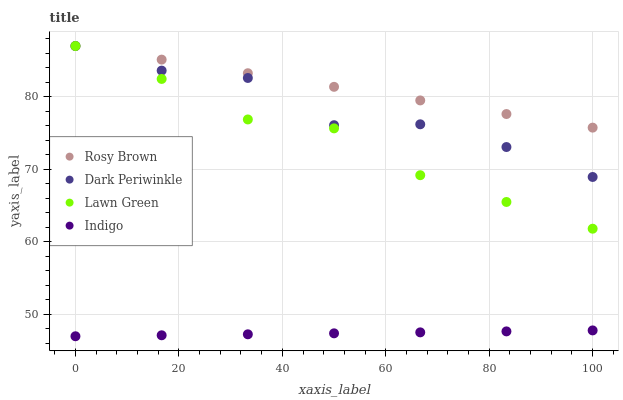Does Indigo have the minimum area under the curve?
Answer yes or no. Yes. Does Rosy Brown have the maximum area under the curve?
Answer yes or no. Yes. Does Rosy Brown have the minimum area under the curve?
Answer yes or no. No. Does Indigo have the maximum area under the curve?
Answer yes or no. No. Is Rosy Brown the smoothest?
Answer yes or no. Yes. Is Dark Periwinkle the roughest?
Answer yes or no. Yes. Is Indigo the smoothest?
Answer yes or no. No. Is Indigo the roughest?
Answer yes or no. No. Does Indigo have the lowest value?
Answer yes or no. Yes. Does Rosy Brown have the lowest value?
Answer yes or no. No. Does Dark Periwinkle have the highest value?
Answer yes or no. Yes. Does Indigo have the highest value?
Answer yes or no. No. Is Indigo less than Dark Periwinkle?
Answer yes or no. Yes. Is Rosy Brown greater than Indigo?
Answer yes or no. Yes. Does Rosy Brown intersect Dark Periwinkle?
Answer yes or no. Yes. Is Rosy Brown less than Dark Periwinkle?
Answer yes or no. No. Is Rosy Brown greater than Dark Periwinkle?
Answer yes or no. No. Does Indigo intersect Dark Periwinkle?
Answer yes or no. No. 